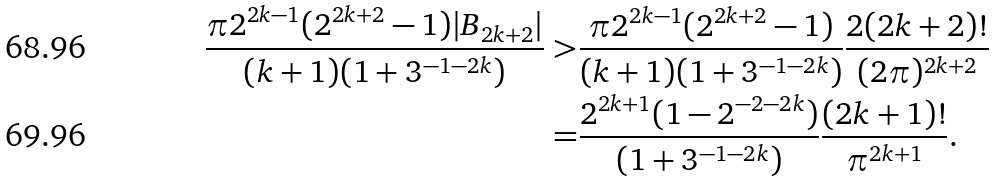<formula> <loc_0><loc_0><loc_500><loc_500>\frac { \pi 2 ^ { 2 k - 1 } ( 2 ^ { 2 k + 2 } - 1 ) | B _ { 2 k + 2 } | } { ( k + 1 ) ( 1 + 3 ^ { - 1 - 2 k } ) } > & \frac { \pi 2 ^ { 2 k - 1 } ( 2 ^ { 2 k + 2 } - 1 ) } { ( k + 1 ) ( 1 + 3 ^ { - 1 - 2 k } ) } \frac { 2 ( 2 k + 2 ) ! } { ( 2 \pi ) ^ { 2 k + 2 } } \\ = & \frac { 2 ^ { 2 k + 1 } ( 1 - 2 ^ { - 2 - 2 k } ) } { ( 1 + 3 ^ { - 1 - 2 k } ) } \frac { ( 2 k + 1 ) ! } { \pi ^ { 2 k + 1 } } .</formula> 